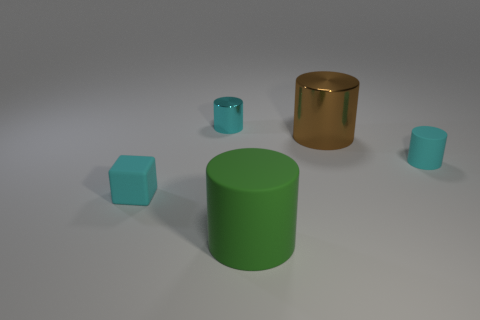Subtract all green cylinders. How many cylinders are left? 3 Subtract all large shiny cylinders. How many cylinders are left? 3 Add 4 large brown cylinders. How many objects exist? 9 Subtract all yellow cylinders. Subtract all yellow cubes. How many cylinders are left? 4 Subtract all cylinders. How many objects are left? 1 Add 3 small cyan metallic cylinders. How many small cyan metallic cylinders exist? 4 Subtract 0 yellow cylinders. How many objects are left? 5 Subtract all cyan shiny objects. Subtract all cyan metal cylinders. How many objects are left? 3 Add 3 cyan shiny objects. How many cyan shiny objects are left? 4 